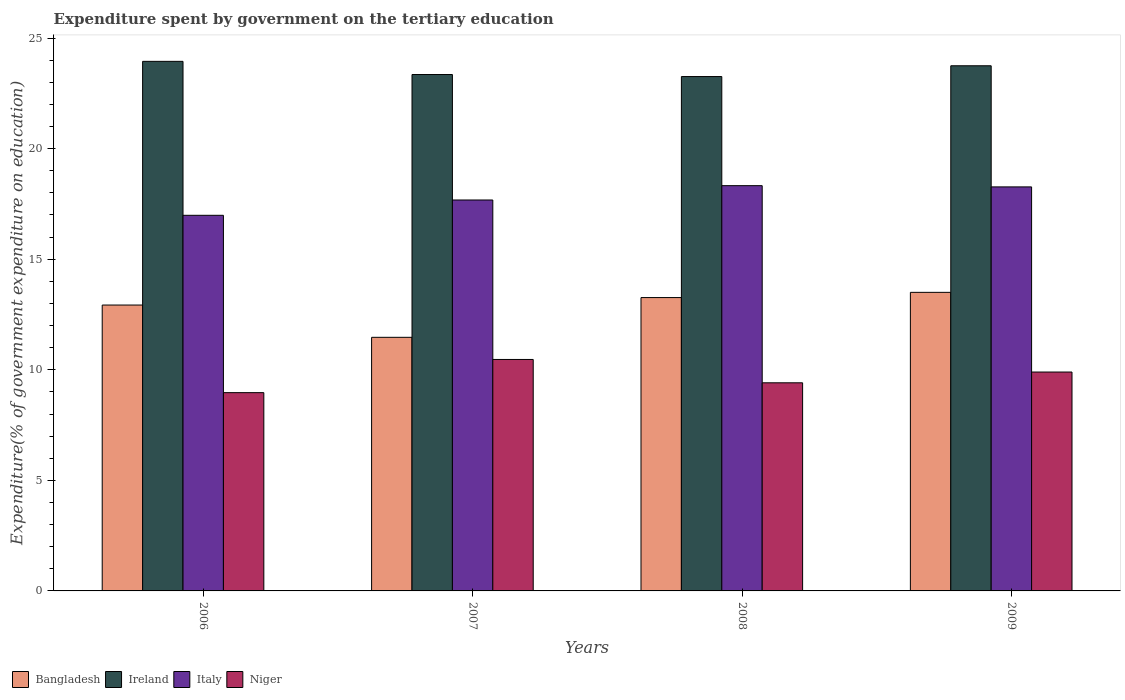How many different coloured bars are there?
Provide a succinct answer. 4. Are the number of bars per tick equal to the number of legend labels?
Provide a succinct answer. Yes. In how many cases, is the number of bars for a given year not equal to the number of legend labels?
Your answer should be very brief. 0. What is the expenditure spent by government on the tertiary education in Ireland in 2006?
Offer a very short reply. 23.95. Across all years, what is the maximum expenditure spent by government on the tertiary education in Ireland?
Offer a terse response. 23.95. Across all years, what is the minimum expenditure spent by government on the tertiary education in Ireland?
Offer a terse response. 23.26. In which year was the expenditure spent by government on the tertiary education in Italy minimum?
Provide a short and direct response. 2006. What is the total expenditure spent by government on the tertiary education in Italy in the graph?
Keep it short and to the point. 71.26. What is the difference between the expenditure spent by government on the tertiary education in Ireland in 2007 and that in 2009?
Offer a terse response. -0.4. What is the difference between the expenditure spent by government on the tertiary education in Bangladesh in 2009 and the expenditure spent by government on the tertiary education in Italy in 2006?
Keep it short and to the point. -3.48. What is the average expenditure spent by government on the tertiary education in Ireland per year?
Ensure brevity in your answer.  23.58. In the year 2006, what is the difference between the expenditure spent by government on the tertiary education in Ireland and expenditure spent by government on the tertiary education in Bangladesh?
Offer a terse response. 11.02. What is the ratio of the expenditure spent by government on the tertiary education in Italy in 2007 to that in 2009?
Provide a short and direct response. 0.97. Is the expenditure spent by government on the tertiary education in Bangladesh in 2006 less than that in 2009?
Your answer should be very brief. Yes. What is the difference between the highest and the second highest expenditure spent by government on the tertiary education in Niger?
Offer a very short reply. 0.57. What is the difference between the highest and the lowest expenditure spent by government on the tertiary education in Bangladesh?
Ensure brevity in your answer.  2.03. Is the sum of the expenditure spent by government on the tertiary education in Bangladesh in 2006 and 2007 greater than the maximum expenditure spent by government on the tertiary education in Ireland across all years?
Your answer should be compact. Yes. What does the 2nd bar from the left in 2009 represents?
Ensure brevity in your answer.  Ireland. What does the 1st bar from the right in 2007 represents?
Your answer should be compact. Niger. Is it the case that in every year, the sum of the expenditure spent by government on the tertiary education in Italy and expenditure spent by government on the tertiary education in Bangladesh is greater than the expenditure spent by government on the tertiary education in Ireland?
Your answer should be compact. Yes. What is the difference between two consecutive major ticks on the Y-axis?
Your answer should be very brief. 5. Are the values on the major ticks of Y-axis written in scientific E-notation?
Ensure brevity in your answer.  No. Does the graph contain grids?
Offer a terse response. No. Where does the legend appear in the graph?
Provide a short and direct response. Bottom left. How many legend labels are there?
Keep it short and to the point. 4. How are the legend labels stacked?
Provide a succinct answer. Horizontal. What is the title of the graph?
Offer a terse response. Expenditure spent by government on the tertiary education. What is the label or title of the X-axis?
Your response must be concise. Years. What is the label or title of the Y-axis?
Your response must be concise. Expenditure(% of government expenditure on education). What is the Expenditure(% of government expenditure on education) in Bangladesh in 2006?
Your answer should be compact. 12.93. What is the Expenditure(% of government expenditure on education) in Ireland in 2006?
Your answer should be very brief. 23.95. What is the Expenditure(% of government expenditure on education) in Italy in 2006?
Provide a short and direct response. 16.99. What is the Expenditure(% of government expenditure on education) of Niger in 2006?
Make the answer very short. 8.97. What is the Expenditure(% of government expenditure on education) in Bangladesh in 2007?
Your answer should be very brief. 11.47. What is the Expenditure(% of government expenditure on education) in Ireland in 2007?
Give a very brief answer. 23.35. What is the Expenditure(% of government expenditure on education) of Italy in 2007?
Offer a very short reply. 17.68. What is the Expenditure(% of government expenditure on education) in Niger in 2007?
Give a very brief answer. 10.47. What is the Expenditure(% of government expenditure on education) in Bangladesh in 2008?
Provide a succinct answer. 13.26. What is the Expenditure(% of government expenditure on education) of Ireland in 2008?
Provide a succinct answer. 23.26. What is the Expenditure(% of government expenditure on education) in Italy in 2008?
Give a very brief answer. 18.33. What is the Expenditure(% of government expenditure on education) of Niger in 2008?
Provide a succinct answer. 9.41. What is the Expenditure(% of government expenditure on education) of Bangladesh in 2009?
Your answer should be compact. 13.5. What is the Expenditure(% of government expenditure on education) of Ireland in 2009?
Keep it short and to the point. 23.75. What is the Expenditure(% of government expenditure on education) of Italy in 2009?
Provide a succinct answer. 18.27. What is the Expenditure(% of government expenditure on education) of Niger in 2009?
Provide a succinct answer. 9.9. Across all years, what is the maximum Expenditure(% of government expenditure on education) in Bangladesh?
Provide a succinct answer. 13.5. Across all years, what is the maximum Expenditure(% of government expenditure on education) of Ireland?
Your answer should be compact. 23.95. Across all years, what is the maximum Expenditure(% of government expenditure on education) of Italy?
Your answer should be compact. 18.33. Across all years, what is the maximum Expenditure(% of government expenditure on education) of Niger?
Your answer should be very brief. 10.47. Across all years, what is the minimum Expenditure(% of government expenditure on education) of Bangladesh?
Provide a succinct answer. 11.47. Across all years, what is the minimum Expenditure(% of government expenditure on education) of Ireland?
Keep it short and to the point. 23.26. Across all years, what is the minimum Expenditure(% of government expenditure on education) of Italy?
Keep it short and to the point. 16.99. Across all years, what is the minimum Expenditure(% of government expenditure on education) in Niger?
Ensure brevity in your answer.  8.97. What is the total Expenditure(% of government expenditure on education) in Bangladesh in the graph?
Your answer should be very brief. 51.16. What is the total Expenditure(% of government expenditure on education) of Ireland in the graph?
Ensure brevity in your answer.  94.3. What is the total Expenditure(% of government expenditure on education) of Italy in the graph?
Your answer should be very brief. 71.26. What is the total Expenditure(% of government expenditure on education) of Niger in the graph?
Keep it short and to the point. 38.74. What is the difference between the Expenditure(% of government expenditure on education) in Bangladesh in 2006 and that in 2007?
Ensure brevity in your answer.  1.46. What is the difference between the Expenditure(% of government expenditure on education) in Ireland in 2006 and that in 2007?
Provide a succinct answer. 0.6. What is the difference between the Expenditure(% of government expenditure on education) in Italy in 2006 and that in 2007?
Offer a terse response. -0.69. What is the difference between the Expenditure(% of government expenditure on education) of Niger in 2006 and that in 2007?
Make the answer very short. -1.5. What is the difference between the Expenditure(% of government expenditure on education) in Bangladesh in 2006 and that in 2008?
Your answer should be compact. -0.34. What is the difference between the Expenditure(% of government expenditure on education) of Ireland in 2006 and that in 2008?
Ensure brevity in your answer.  0.69. What is the difference between the Expenditure(% of government expenditure on education) of Italy in 2006 and that in 2008?
Give a very brief answer. -1.34. What is the difference between the Expenditure(% of government expenditure on education) of Niger in 2006 and that in 2008?
Ensure brevity in your answer.  -0.45. What is the difference between the Expenditure(% of government expenditure on education) in Bangladesh in 2006 and that in 2009?
Give a very brief answer. -0.57. What is the difference between the Expenditure(% of government expenditure on education) in Ireland in 2006 and that in 2009?
Your response must be concise. 0.2. What is the difference between the Expenditure(% of government expenditure on education) in Italy in 2006 and that in 2009?
Provide a short and direct response. -1.28. What is the difference between the Expenditure(% of government expenditure on education) in Niger in 2006 and that in 2009?
Make the answer very short. -0.93. What is the difference between the Expenditure(% of government expenditure on education) in Bangladesh in 2007 and that in 2008?
Your answer should be compact. -1.8. What is the difference between the Expenditure(% of government expenditure on education) of Ireland in 2007 and that in 2008?
Offer a very short reply. 0.09. What is the difference between the Expenditure(% of government expenditure on education) of Italy in 2007 and that in 2008?
Your answer should be very brief. -0.65. What is the difference between the Expenditure(% of government expenditure on education) in Niger in 2007 and that in 2008?
Keep it short and to the point. 1.06. What is the difference between the Expenditure(% of government expenditure on education) in Bangladesh in 2007 and that in 2009?
Provide a short and direct response. -2.03. What is the difference between the Expenditure(% of government expenditure on education) in Ireland in 2007 and that in 2009?
Ensure brevity in your answer.  -0.4. What is the difference between the Expenditure(% of government expenditure on education) in Italy in 2007 and that in 2009?
Offer a very short reply. -0.59. What is the difference between the Expenditure(% of government expenditure on education) of Niger in 2007 and that in 2009?
Offer a very short reply. 0.57. What is the difference between the Expenditure(% of government expenditure on education) of Bangladesh in 2008 and that in 2009?
Provide a short and direct response. -0.24. What is the difference between the Expenditure(% of government expenditure on education) in Ireland in 2008 and that in 2009?
Give a very brief answer. -0.49. What is the difference between the Expenditure(% of government expenditure on education) in Italy in 2008 and that in 2009?
Make the answer very short. 0.06. What is the difference between the Expenditure(% of government expenditure on education) in Niger in 2008 and that in 2009?
Offer a very short reply. -0.49. What is the difference between the Expenditure(% of government expenditure on education) in Bangladesh in 2006 and the Expenditure(% of government expenditure on education) in Ireland in 2007?
Provide a succinct answer. -10.42. What is the difference between the Expenditure(% of government expenditure on education) of Bangladesh in 2006 and the Expenditure(% of government expenditure on education) of Italy in 2007?
Your response must be concise. -4.75. What is the difference between the Expenditure(% of government expenditure on education) of Bangladesh in 2006 and the Expenditure(% of government expenditure on education) of Niger in 2007?
Offer a terse response. 2.46. What is the difference between the Expenditure(% of government expenditure on education) in Ireland in 2006 and the Expenditure(% of government expenditure on education) in Italy in 2007?
Provide a short and direct response. 6.27. What is the difference between the Expenditure(% of government expenditure on education) in Ireland in 2006 and the Expenditure(% of government expenditure on education) in Niger in 2007?
Offer a very short reply. 13.48. What is the difference between the Expenditure(% of government expenditure on education) in Italy in 2006 and the Expenditure(% of government expenditure on education) in Niger in 2007?
Make the answer very short. 6.52. What is the difference between the Expenditure(% of government expenditure on education) in Bangladesh in 2006 and the Expenditure(% of government expenditure on education) in Ireland in 2008?
Your response must be concise. -10.33. What is the difference between the Expenditure(% of government expenditure on education) of Bangladesh in 2006 and the Expenditure(% of government expenditure on education) of Italy in 2008?
Provide a succinct answer. -5.4. What is the difference between the Expenditure(% of government expenditure on education) in Bangladesh in 2006 and the Expenditure(% of government expenditure on education) in Niger in 2008?
Ensure brevity in your answer.  3.52. What is the difference between the Expenditure(% of government expenditure on education) of Ireland in 2006 and the Expenditure(% of government expenditure on education) of Italy in 2008?
Give a very brief answer. 5.62. What is the difference between the Expenditure(% of government expenditure on education) of Ireland in 2006 and the Expenditure(% of government expenditure on education) of Niger in 2008?
Ensure brevity in your answer.  14.54. What is the difference between the Expenditure(% of government expenditure on education) in Italy in 2006 and the Expenditure(% of government expenditure on education) in Niger in 2008?
Ensure brevity in your answer.  7.57. What is the difference between the Expenditure(% of government expenditure on education) in Bangladesh in 2006 and the Expenditure(% of government expenditure on education) in Ireland in 2009?
Keep it short and to the point. -10.82. What is the difference between the Expenditure(% of government expenditure on education) in Bangladesh in 2006 and the Expenditure(% of government expenditure on education) in Italy in 2009?
Give a very brief answer. -5.34. What is the difference between the Expenditure(% of government expenditure on education) of Bangladesh in 2006 and the Expenditure(% of government expenditure on education) of Niger in 2009?
Give a very brief answer. 3.03. What is the difference between the Expenditure(% of government expenditure on education) in Ireland in 2006 and the Expenditure(% of government expenditure on education) in Italy in 2009?
Your answer should be very brief. 5.68. What is the difference between the Expenditure(% of government expenditure on education) of Ireland in 2006 and the Expenditure(% of government expenditure on education) of Niger in 2009?
Offer a terse response. 14.05. What is the difference between the Expenditure(% of government expenditure on education) in Italy in 2006 and the Expenditure(% of government expenditure on education) in Niger in 2009?
Give a very brief answer. 7.09. What is the difference between the Expenditure(% of government expenditure on education) in Bangladesh in 2007 and the Expenditure(% of government expenditure on education) in Ireland in 2008?
Offer a very short reply. -11.79. What is the difference between the Expenditure(% of government expenditure on education) of Bangladesh in 2007 and the Expenditure(% of government expenditure on education) of Italy in 2008?
Offer a terse response. -6.86. What is the difference between the Expenditure(% of government expenditure on education) in Bangladesh in 2007 and the Expenditure(% of government expenditure on education) in Niger in 2008?
Provide a short and direct response. 2.06. What is the difference between the Expenditure(% of government expenditure on education) in Ireland in 2007 and the Expenditure(% of government expenditure on education) in Italy in 2008?
Provide a short and direct response. 5.03. What is the difference between the Expenditure(% of government expenditure on education) in Ireland in 2007 and the Expenditure(% of government expenditure on education) in Niger in 2008?
Offer a very short reply. 13.94. What is the difference between the Expenditure(% of government expenditure on education) in Italy in 2007 and the Expenditure(% of government expenditure on education) in Niger in 2008?
Offer a very short reply. 8.27. What is the difference between the Expenditure(% of government expenditure on education) in Bangladesh in 2007 and the Expenditure(% of government expenditure on education) in Ireland in 2009?
Offer a very short reply. -12.28. What is the difference between the Expenditure(% of government expenditure on education) of Bangladesh in 2007 and the Expenditure(% of government expenditure on education) of Italy in 2009?
Make the answer very short. -6.8. What is the difference between the Expenditure(% of government expenditure on education) in Bangladesh in 2007 and the Expenditure(% of government expenditure on education) in Niger in 2009?
Provide a succinct answer. 1.57. What is the difference between the Expenditure(% of government expenditure on education) of Ireland in 2007 and the Expenditure(% of government expenditure on education) of Italy in 2009?
Your answer should be very brief. 5.08. What is the difference between the Expenditure(% of government expenditure on education) in Ireland in 2007 and the Expenditure(% of government expenditure on education) in Niger in 2009?
Your answer should be compact. 13.45. What is the difference between the Expenditure(% of government expenditure on education) of Italy in 2007 and the Expenditure(% of government expenditure on education) of Niger in 2009?
Your answer should be compact. 7.78. What is the difference between the Expenditure(% of government expenditure on education) of Bangladesh in 2008 and the Expenditure(% of government expenditure on education) of Ireland in 2009?
Keep it short and to the point. -10.48. What is the difference between the Expenditure(% of government expenditure on education) in Bangladesh in 2008 and the Expenditure(% of government expenditure on education) in Italy in 2009?
Keep it short and to the point. -5.01. What is the difference between the Expenditure(% of government expenditure on education) of Bangladesh in 2008 and the Expenditure(% of government expenditure on education) of Niger in 2009?
Offer a very short reply. 3.37. What is the difference between the Expenditure(% of government expenditure on education) of Ireland in 2008 and the Expenditure(% of government expenditure on education) of Italy in 2009?
Provide a short and direct response. 4.99. What is the difference between the Expenditure(% of government expenditure on education) in Ireland in 2008 and the Expenditure(% of government expenditure on education) in Niger in 2009?
Make the answer very short. 13.36. What is the difference between the Expenditure(% of government expenditure on education) in Italy in 2008 and the Expenditure(% of government expenditure on education) in Niger in 2009?
Offer a very short reply. 8.43. What is the average Expenditure(% of government expenditure on education) of Bangladesh per year?
Offer a terse response. 12.79. What is the average Expenditure(% of government expenditure on education) in Ireland per year?
Offer a terse response. 23.58. What is the average Expenditure(% of government expenditure on education) in Italy per year?
Your response must be concise. 17.81. What is the average Expenditure(% of government expenditure on education) in Niger per year?
Give a very brief answer. 9.69. In the year 2006, what is the difference between the Expenditure(% of government expenditure on education) in Bangladesh and Expenditure(% of government expenditure on education) in Ireland?
Your answer should be compact. -11.02. In the year 2006, what is the difference between the Expenditure(% of government expenditure on education) of Bangladesh and Expenditure(% of government expenditure on education) of Italy?
Offer a very short reply. -4.06. In the year 2006, what is the difference between the Expenditure(% of government expenditure on education) of Bangladesh and Expenditure(% of government expenditure on education) of Niger?
Give a very brief answer. 3.96. In the year 2006, what is the difference between the Expenditure(% of government expenditure on education) in Ireland and Expenditure(% of government expenditure on education) in Italy?
Offer a terse response. 6.96. In the year 2006, what is the difference between the Expenditure(% of government expenditure on education) in Ireland and Expenditure(% of government expenditure on education) in Niger?
Your answer should be compact. 14.98. In the year 2006, what is the difference between the Expenditure(% of government expenditure on education) of Italy and Expenditure(% of government expenditure on education) of Niger?
Provide a short and direct response. 8.02. In the year 2007, what is the difference between the Expenditure(% of government expenditure on education) of Bangladesh and Expenditure(% of government expenditure on education) of Ireland?
Your answer should be very brief. -11.88. In the year 2007, what is the difference between the Expenditure(% of government expenditure on education) of Bangladesh and Expenditure(% of government expenditure on education) of Italy?
Keep it short and to the point. -6.21. In the year 2007, what is the difference between the Expenditure(% of government expenditure on education) in Bangladesh and Expenditure(% of government expenditure on education) in Niger?
Provide a succinct answer. 1. In the year 2007, what is the difference between the Expenditure(% of government expenditure on education) of Ireland and Expenditure(% of government expenditure on education) of Italy?
Give a very brief answer. 5.67. In the year 2007, what is the difference between the Expenditure(% of government expenditure on education) in Ireland and Expenditure(% of government expenditure on education) in Niger?
Offer a terse response. 12.88. In the year 2007, what is the difference between the Expenditure(% of government expenditure on education) of Italy and Expenditure(% of government expenditure on education) of Niger?
Offer a terse response. 7.21. In the year 2008, what is the difference between the Expenditure(% of government expenditure on education) in Bangladesh and Expenditure(% of government expenditure on education) in Ireland?
Offer a terse response. -9.99. In the year 2008, what is the difference between the Expenditure(% of government expenditure on education) in Bangladesh and Expenditure(% of government expenditure on education) in Italy?
Make the answer very short. -5.06. In the year 2008, what is the difference between the Expenditure(% of government expenditure on education) of Bangladesh and Expenditure(% of government expenditure on education) of Niger?
Give a very brief answer. 3.85. In the year 2008, what is the difference between the Expenditure(% of government expenditure on education) in Ireland and Expenditure(% of government expenditure on education) in Italy?
Provide a short and direct response. 4.93. In the year 2008, what is the difference between the Expenditure(% of government expenditure on education) in Ireland and Expenditure(% of government expenditure on education) in Niger?
Provide a succinct answer. 13.85. In the year 2008, what is the difference between the Expenditure(% of government expenditure on education) in Italy and Expenditure(% of government expenditure on education) in Niger?
Your answer should be compact. 8.91. In the year 2009, what is the difference between the Expenditure(% of government expenditure on education) in Bangladesh and Expenditure(% of government expenditure on education) in Ireland?
Offer a very short reply. -10.25. In the year 2009, what is the difference between the Expenditure(% of government expenditure on education) in Bangladesh and Expenditure(% of government expenditure on education) in Italy?
Offer a terse response. -4.77. In the year 2009, what is the difference between the Expenditure(% of government expenditure on education) in Bangladesh and Expenditure(% of government expenditure on education) in Niger?
Your answer should be very brief. 3.6. In the year 2009, what is the difference between the Expenditure(% of government expenditure on education) of Ireland and Expenditure(% of government expenditure on education) of Italy?
Your answer should be compact. 5.48. In the year 2009, what is the difference between the Expenditure(% of government expenditure on education) of Ireland and Expenditure(% of government expenditure on education) of Niger?
Give a very brief answer. 13.85. In the year 2009, what is the difference between the Expenditure(% of government expenditure on education) of Italy and Expenditure(% of government expenditure on education) of Niger?
Provide a succinct answer. 8.37. What is the ratio of the Expenditure(% of government expenditure on education) of Bangladesh in 2006 to that in 2007?
Give a very brief answer. 1.13. What is the ratio of the Expenditure(% of government expenditure on education) in Ireland in 2006 to that in 2007?
Give a very brief answer. 1.03. What is the ratio of the Expenditure(% of government expenditure on education) in Italy in 2006 to that in 2007?
Make the answer very short. 0.96. What is the ratio of the Expenditure(% of government expenditure on education) in Niger in 2006 to that in 2007?
Offer a very short reply. 0.86. What is the ratio of the Expenditure(% of government expenditure on education) in Bangladesh in 2006 to that in 2008?
Offer a terse response. 0.97. What is the ratio of the Expenditure(% of government expenditure on education) in Ireland in 2006 to that in 2008?
Offer a terse response. 1.03. What is the ratio of the Expenditure(% of government expenditure on education) in Italy in 2006 to that in 2008?
Ensure brevity in your answer.  0.93. What is the ratio of the Expenditure(% of government expenditure on education) of Niger in 2006 to that in 2008?
Make the answer very short. 0.95. What is the ratio of the Expenditure(% of government expenditure on education) of Bangladesh in 2006 to that in 2009?
Your answer should be very brief. 0.96. What is the ratio of the Expenditure(% of government expenditure on education) in Ireland in 2006 to that in 2009?
Your answer should be very brief. 1.01. What is the ratio of the Expenditure(% of government expenditure on education) in Italy in 2006 to that in 2009?
Offer a terse response. 0.93. What is the ratio of the Expenditure(% of government expenditure on education) of Niger in 2006 to that in 2009?
Offer a very short reply. 0.91. What is the ratio of the Expenditure(% of government expenditure on education) in Bangladesh in 2007 to that in 2008?
Your response must be concise. 0.86. What is the ratio of the Expenditure(% of government expenditure on education) in Ireland in 2007 to that in 2008?
Keep it short and to the point. 1. What is the ratio of the Expenditure(% of government expenditure on education) in Italy in 2007 to that in 2008?
Offer a very short reply. 0.96. What is the ratio of the Expenditure(% of government expenditure on education) of Niger in 2007 to that in 2008?
Offer a terse response. 1.11. What is the ratio of the Expenditure(% of government expenditure on education) of Bangladesh in 2007 to that in 2009?
Your answer should be very brief. 0.85. What is the ratio of the Expenditure(% of government expenditure on education) of Ireland in 2007 to that in 2009?
Offer a terse response. 0.98. What is the ratio of the Expenditure(% of government expenditure on education) of Italy in 2007 to that in 2009?
Give a very brief answer. 0.97. What is the ratio of the Expenditure(% of government expenditure on education) in Niger in 2007 to that in 2009?
Keep it short and to the point. 1.06. What is the ratio of the Expenditure(% of government expenditure on education) of Bangladesh in 2008 to that in 2009?
Offer a very short reply. 0.98. What is the ratio of the Expenditure(% of government expenditure on education) of Ireland in 2008 to that in 2009?
Provide a succinct answer. 0.98. What is the ratio of the Expenditure(% of government expenditure on education) of Niger in 2008 to that in 2009?
Ensure brevity in your answer.  0.95. What is the difference between the highest and the second highest Expenditure(% of government expenditure on education) of Bangladesh?
Your answer should be very brief. 0.24. What is the difference between the highest and the second highest Expenditure(% of government expenditure on education) of Ireland?
Offer a very short reply. 0.2. What is the difference between the highest and the second highest Expenditure(% of government expenditure on education) in Italy?
Keep it short and to the point. 0.06. What is the difference between the highest and the second highest Expenditure(% of government expenditure on education) of Niger?
Offer a terse response. 0.57. What is the difference between the highest and the lowest Expenditure(% of government expenditure on education) in Bangladesh?
Your answer should be compact. 2.03. What is the difference between the highest and the lowest Expenditure(% of government expenditure on education) in Ireland?
Your answer should be compact. 0.69. What is the difference between the highest and the lowest Expenditure(% of government expenditure on education) in Italy?
Provide a succinct answer. 1.34. What is the difference between the highest and the lowest Expenditure(% of government expenditure on education) in Niger?
Provide a succinct answer. 1.5. 